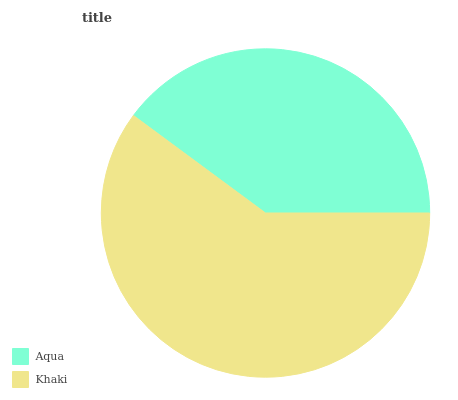Is Aqua the minimum?
Answer yes or no. Yes. Is Khaki the maximum?
Answer yes or no. Yes. Is Khaki the minimum?
Answer yes or no. No. Is Khaki greater than Aqua?
Answer yes or no. Yes. Is Aqua less than Khaki?
Answer yes or no. Yes. Is Aqua greater than Khaki?
Answer yes or no. No. Is Khaki less than Aqua?
Answer yes or no. No. Is Khaki the high median?
Answer yes or no. Yes. Is Aqua the low median?
Answer yes or no. Yes. Is Aqua the high median?
Answer yes or no. No. Is Khaki the low median?
Answer yes or no. No. 